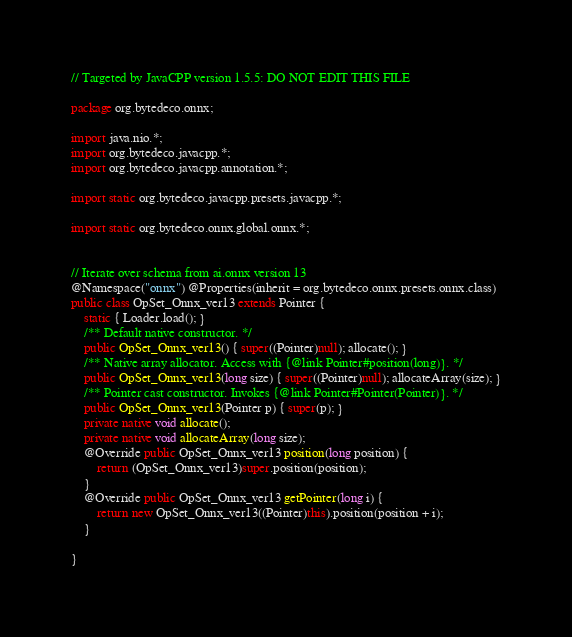<code> <loc_0><loc_0><loc_500><loc_500><_Java_>// Targeted by JavaCPP version 1.5.5: DO NOT EDIT THIS FILE

package org.bytedeco.onnx;

import java.nio.*;
import org.bytedeco.javacpp.*;
import org.bytedeco.javacpp.annotation.*;

import static org.bytedeco.javacpp.presets.javacpp.*;

import static org.bytedeco.onnx.global.onnx.*;


// Iterate over schema from ai.onnx version 13
@Namespace("onnx") @Properties(inherit = org.bytedeco.onnx.presets.onnx.class)
public class OpSet_Onnx_ver13 extends Pointer {
    static { Loader.load(); }
    /** Default native constructor. */
    public OpSet_Onnx_ver13() { super((Pointer)null); allocate(); }
    /** Native array allocator. Access with {@link Pointer#position(long)}. */
    public OpSet_Onnx_ver13(long size) { super((Pointer)null); allocateArray(size); }
    /** Pointer cast constructor. Invokes {@link Pointer#Pointer(Pointer)}. */
    public OpSet_Onnx_ver13(Pointer p) { super(p); }
    private native void allocate();
    private native void allocateArray(long size);
    @Override public OpSet_Onnx_ver13 position(long position) {
        return (OpSet_Onnx_ver13)super.position(position);
    }
    @Override public OpSet_Onnx_ver13 getPointer(long i) {
        return new OpSet_Onnx_ver13((Pointer)this).position(position + i);
    }

}
</code> 